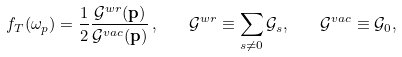Convert formula to latex. <formula><loc_0><loc_0><loc_500><loc_500>f _ { T } ( \omega _ { p } ) = \frac { 1 } { 2 } \frac { { \mathcal { G } } ^ { w r } ( { \mathbf p } ) } { { \mathcal { G } } ^ { v a c } ( { \mathbf p } ) } \, , \quad \mathcal { G } ^ { w r } \equiv \sum _ { s \neq 0 } { \mathcal { G } } _ { s } , \quad \mathcal { G } ^ { v a c } \equiv \mathcal { G } _ { 0 } ,</formula> 